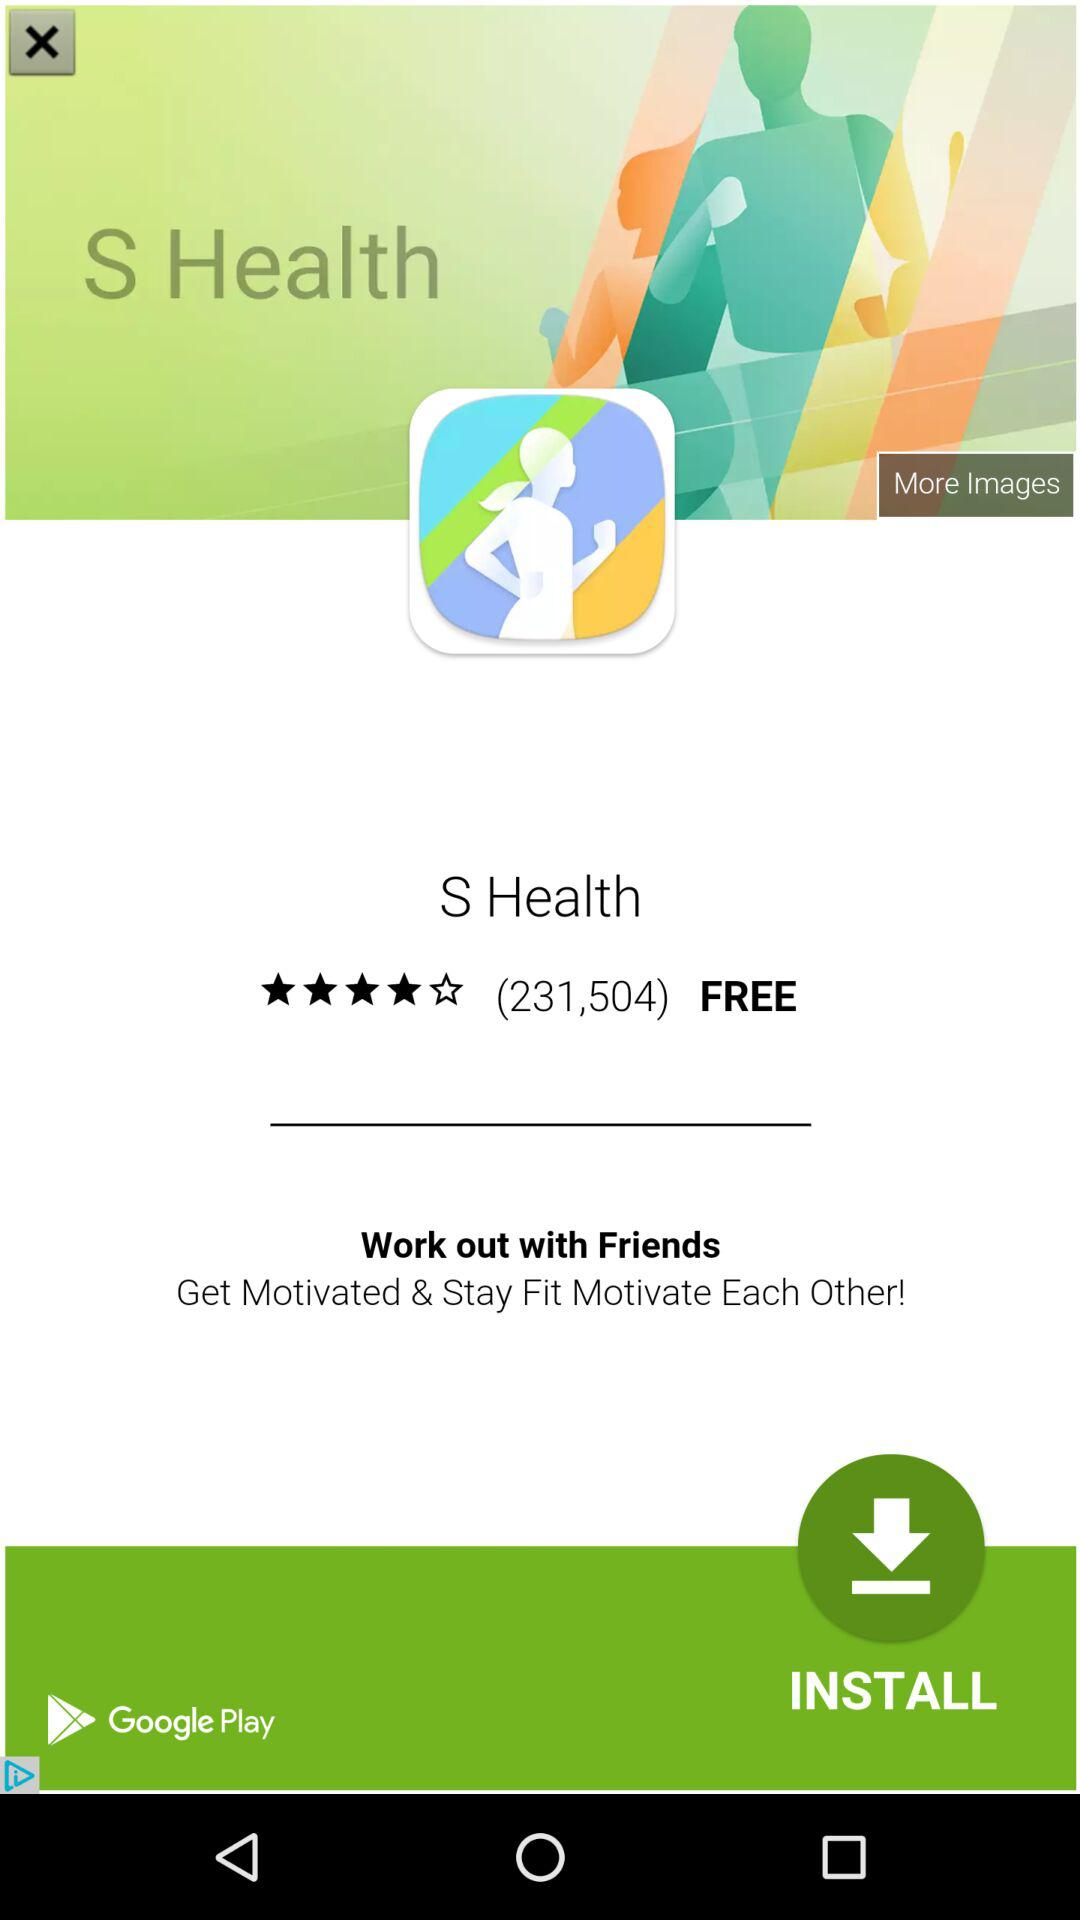How many "Work" is there? The number of "Work" is 20. 